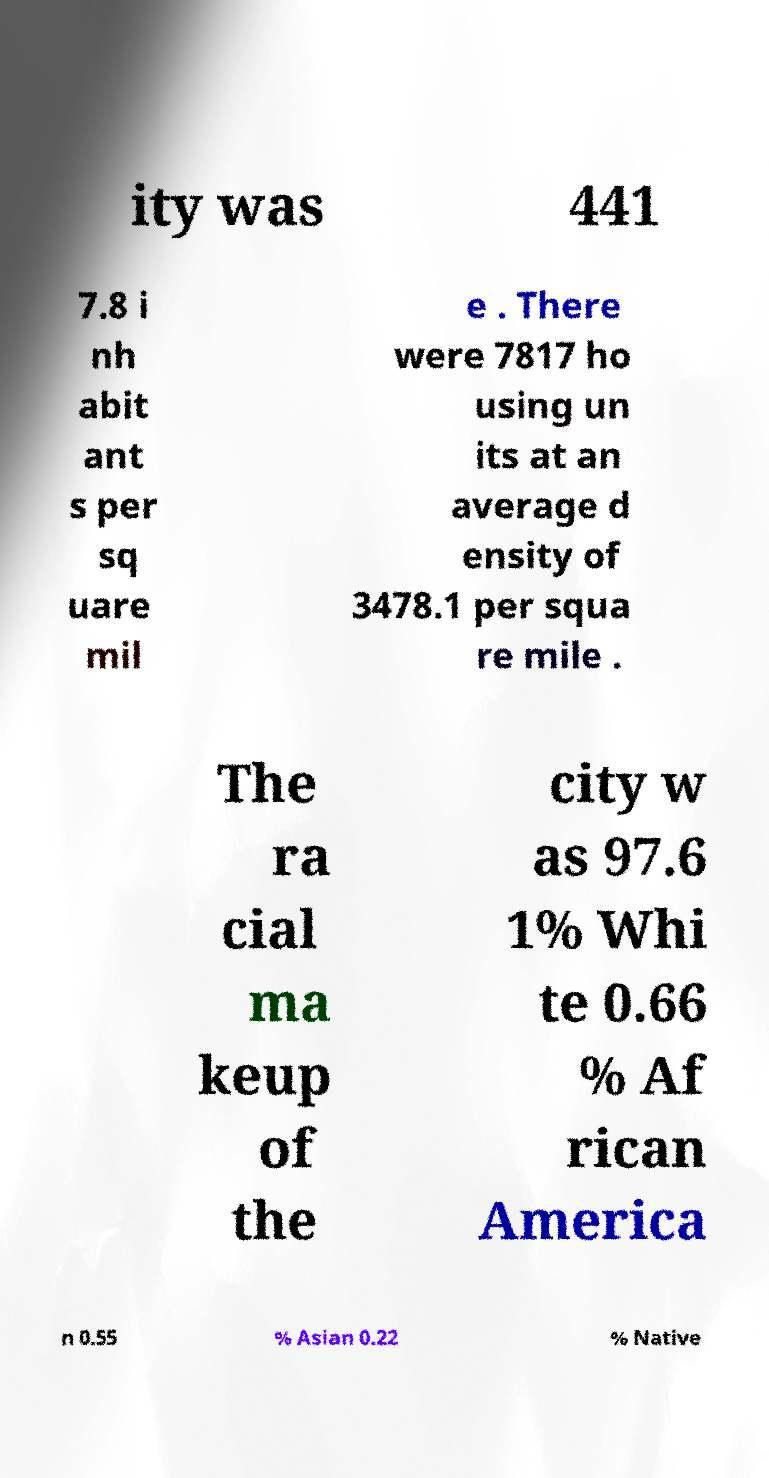Can you read and provide the text displayed in the image?This photo seems to have some interesting text. Can you extract and type it out for me? ity was 441 7.8 i nh abit ant s per sq uare mil e . There were 7817 ho using un its at an average d ensity of 3478.1 per squa re mile . The ra cial ma keup of the city w as 97.6 1% Whi te 0.66 % Af rican America n 0.55 % Asian 0.22 % Native 